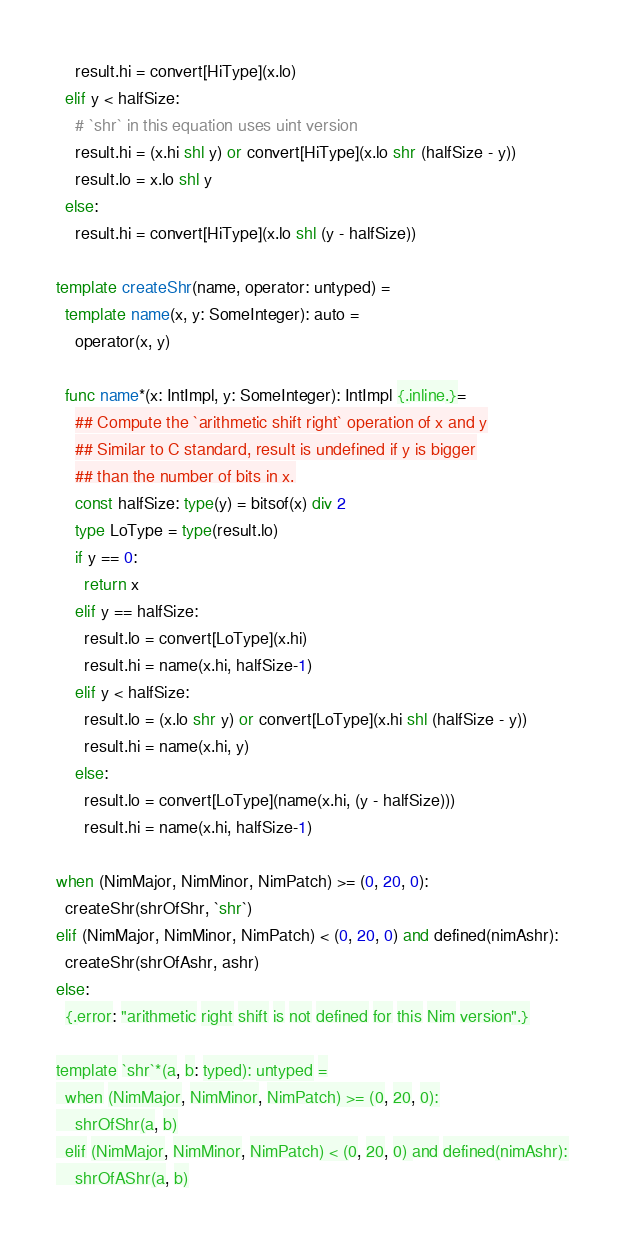Convert code to text. <code><loc_0><loc_0><loc_500><loc_500><_Nim_>    result.hi = convert[HiType](x.lo)
  elif y < halfSize:
    # `shr` in this equation uses uint version
    result.hi = (x.hi shl y) or convert[HiType](x.lo shr (halfSize - y))
    result.lo = x.lo shl y
  else:
    result.hi = convert[HiType](x.lo shl (y - halfSize))

template createShr(name, operator: untyped) =
  template name(x, y: SomeInteger): auto =
    operator(x, y)

  func name*(x: IntImpl, y: SomeInteger): IntImpl {.inline.}=
    ## Compute the `arithmetic shift right` operation of x and y
    ## Similar to C standard, result is undefined if y is bigger
    ## than the number of bits in x.
    const halfSize: type(y) = bitsof(x) div 2
    type LoType = type(result.lo)
    if y == 0:
      return x
    elif y == halfSize:
      result.lo = convert[LoType](x.hi)
      result.hi = name(x.hi, halfSize-1)
    elif y < halfSize:
      result.lo = (x.lo shr y) or convert[LoType](x.hi shl (halfSize - y))
      result.hi = name(x.hi, y)
    else:
      result.lo = convert[LoType](name(x.hi, (y - halfSize)))
      result.hi = name(x.hi, halfSize-1)

when (NimMajor, NimMinor, NimPatch) >= (0, 20, 0):
  createShr(shrOfShr, `shr`)
elif (NimMajor, NimMinor, NimPatch) < (0, 20, 0) and defined(nimAshr):
  createShr(shrOfAshr, ashr)
else:
  {.error: "arithmetic right shift is not defined for this Nim version".}

template `shr`*(a, b: typed): untyped =
  when (NimMajor, NimMinor, NimPatch) >= (0, 20, 0):
    shrOfShr(a, b)
  elif (NimMajor, NimMinor, NimPatch) < (0, 20, 0) and defined(nimAshr):
    shrOfAShr(a, b)
</code> 